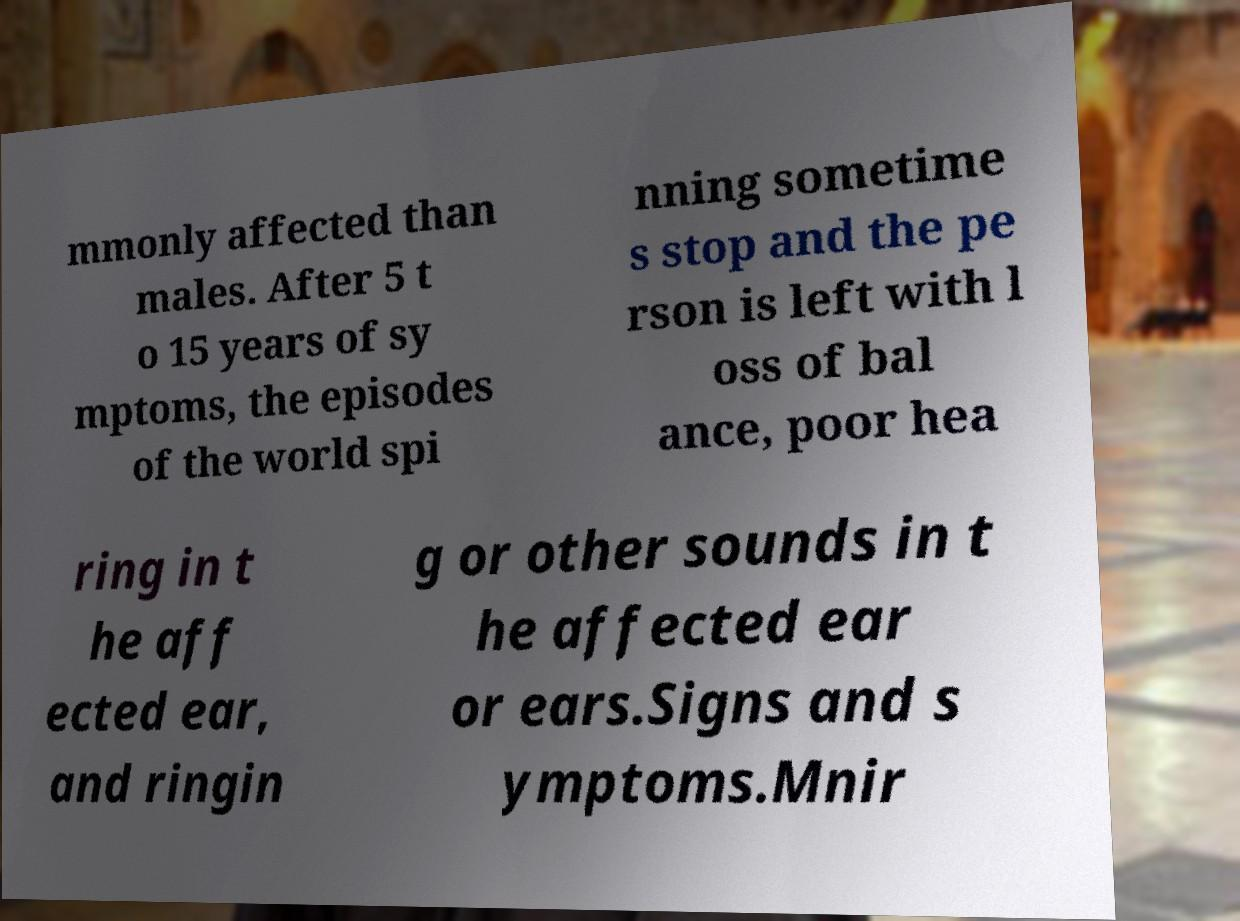Could you extract and type out the text from this image? mmonly affected than males. After 5 t o 15 years of sy mptoms, the episodes of the world spi nning sometime s stop and the pe rson is left with l oss of bal ance, poor hea ring in t he aff ected ear, and ringin g or other sounds in t he affected ear or ears.Signs and s ymptoms.Mnir 